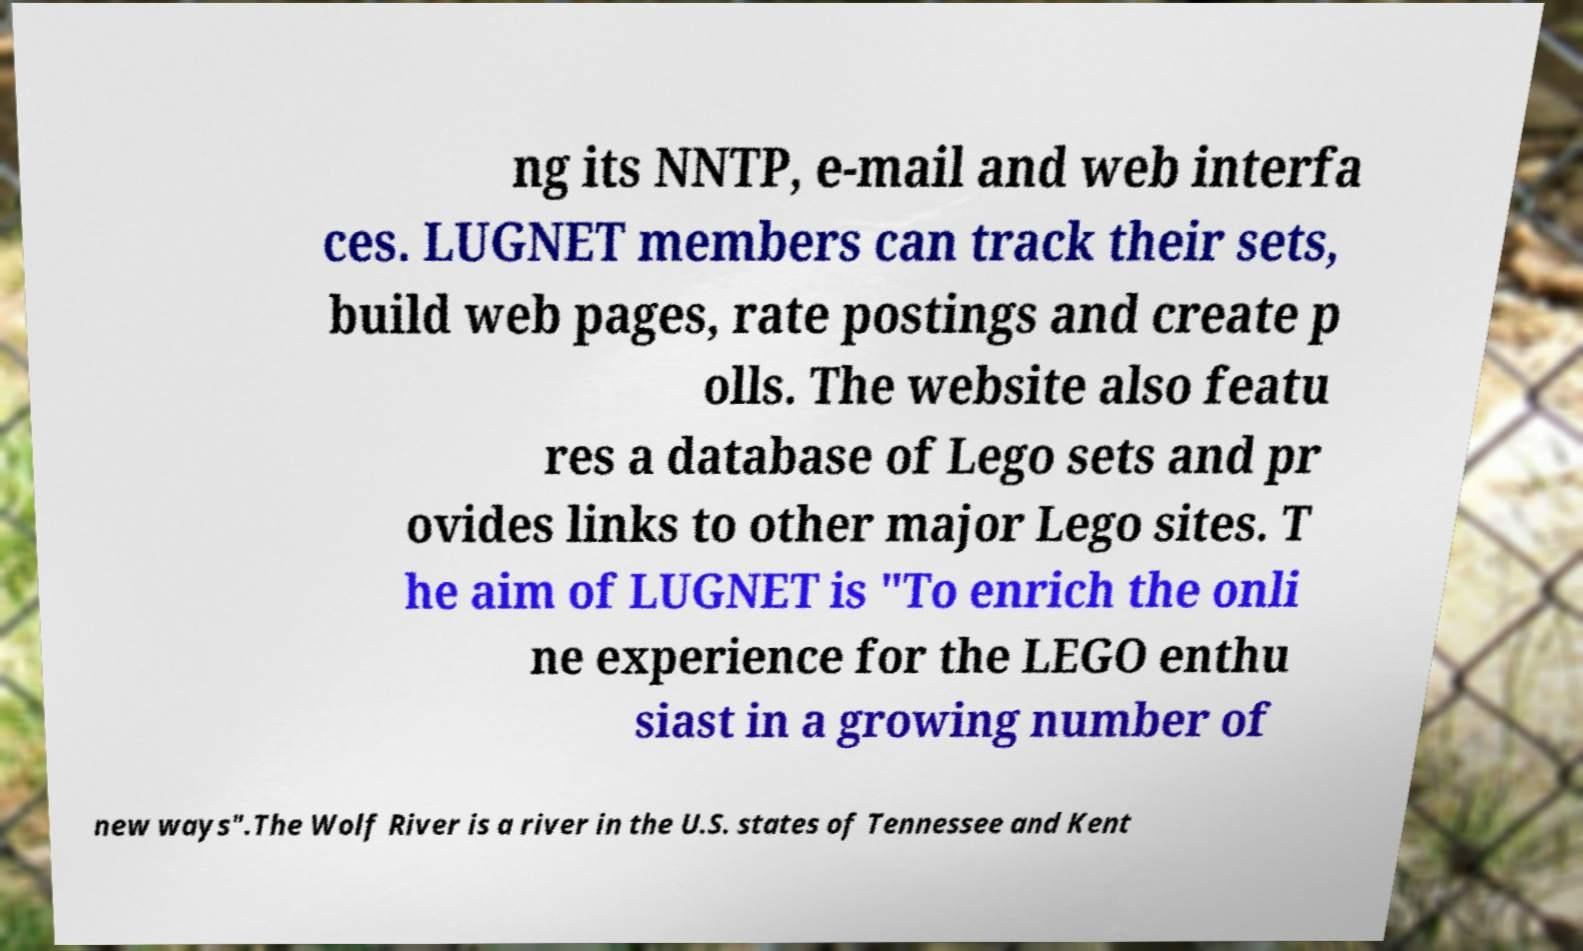Can you accurately transcribe the text from the provided image for me? ng its NNTP, e-mail and web interfa ces. LUGNET members can track their sets, build web pages, rate postings and create p olls. The website also featu res a database of Lego sets and pr ovides links to other major Lego sites. T he aim of LUGNET is "To enrich the onli ne experience for the LEGO enthu siast in a growing number of new ways".The Wolf River is a river in the U.S. states of Tennessee and Kent 